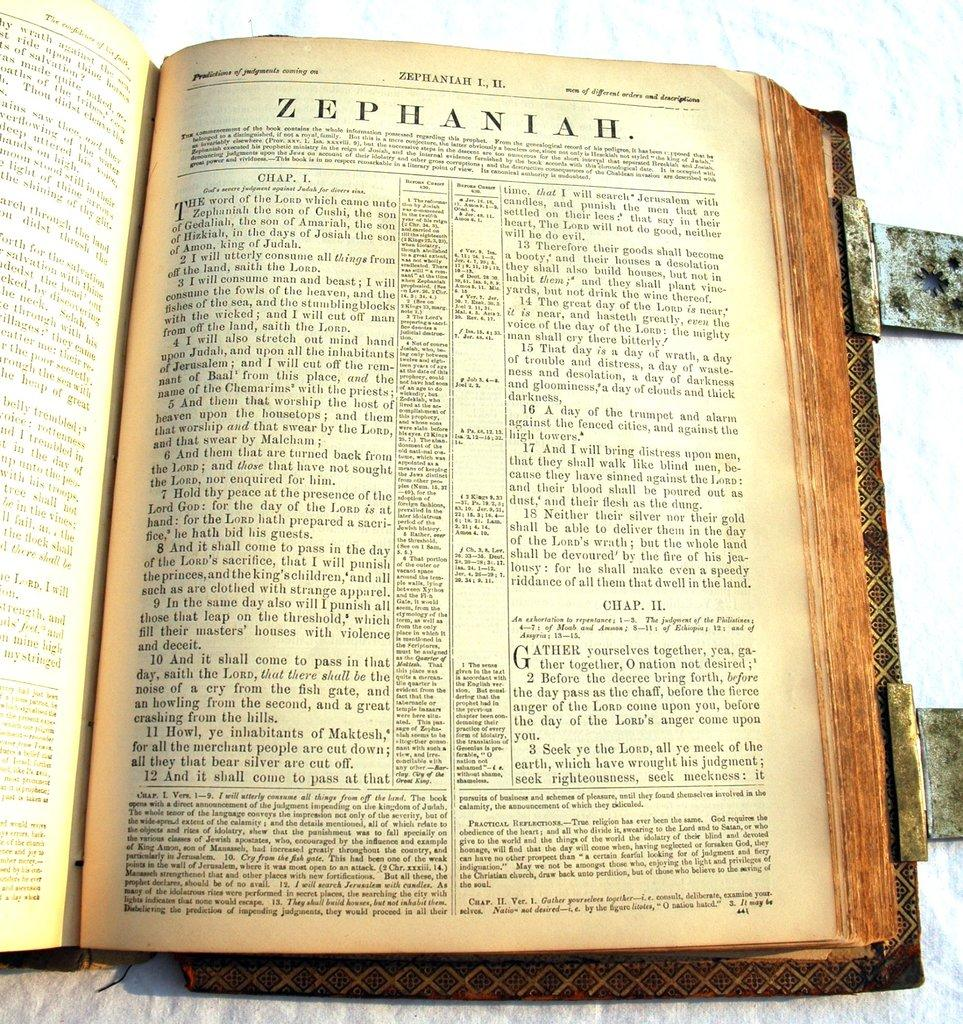<image>
Give a short and clear explanation of the subsequent image. Opened book set on a page with the title "ZEPHANIAH". 